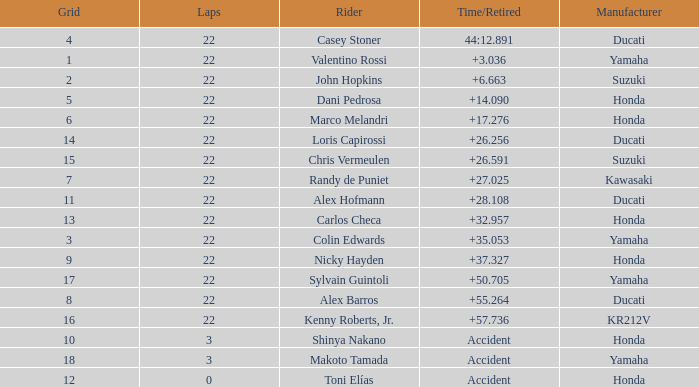What is the average grid for competitors who had more than 22 laps and time/retired of +17.276? None. 